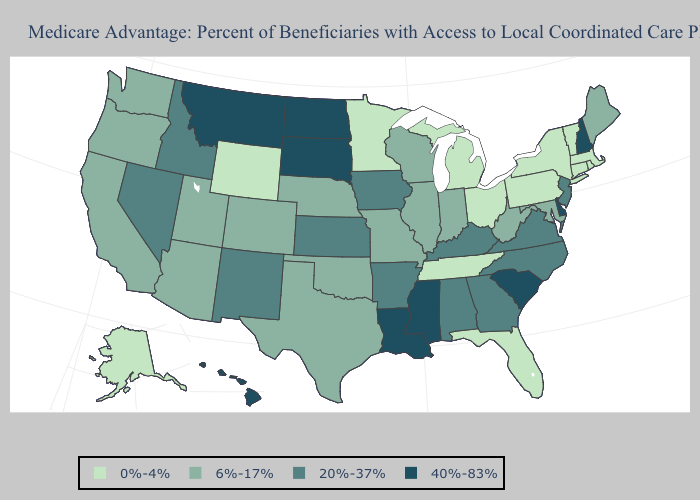What is the value of South Carolina?
Keep it brief. 40%-83%. Does New Mexico have the highest value in the USA?
Quick response, please. No. Which states have the lowest value in the USA?
Answer briefly. Connecticut, Florida, Massachusetts, Michigan, Minnesota, New York, Ohio, Pennsylvania, Rhode Island, Alaska, Tennessee, Vermont, Wyoming. Name the states that have a value in the range 40%-83%?
Short answer required. Delaware, Hawaii, Louisiana, Mississippi, Montana, North Dakota, New Hampshire, South Carolina, South Dakota. Does Hawaii have a lower value than Vermont?
Quick response, please. No. What is the value of Idaho?
Be succinct. 20%-37%. What is the value of Tennessee?
Write a very short answer. 0%-4%. Name the states that have a value in the range 0%-4%?
Concise answer only. Connecticut, Florida, Massachusetts, Michigan, Minnesota, New York, Ohio, Pennsylvania, Rhode Island, Alaska, Tennessee, Vermont, Wyoming. What is the value of Nevada?
Answer briefly. 20%-37%. What is the highest value in the USA?
Short answer required. 40%-83%. What is the highest value in the Northeast ?
Short answer required. 40%-83%. Does Oregon have a lower value than Alabama?
Quick response, please. Yes. Does the map have missing data?
Answer briefly. No. Name the states that have a value in the range 40%-83%?
Quick response, please. Delaware, Hawaii, Louisiana, Mississippi, Montana, North Dakota, New Hampshire, South Carolina, South Dakota. What is the value of Massachusetts?
Be succinct. 0%-4%. 